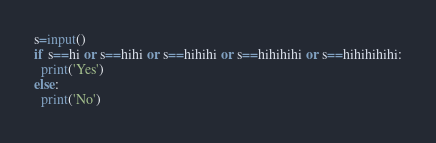<code> <loc_0><loc_0><loc_500><loc_500><_Python_>s=input()
if s==hi or s==hihi or s==hihihi or s==hihihihi or s==hihihihihi:
  print('Yes')
else:
  print('No')</code> 